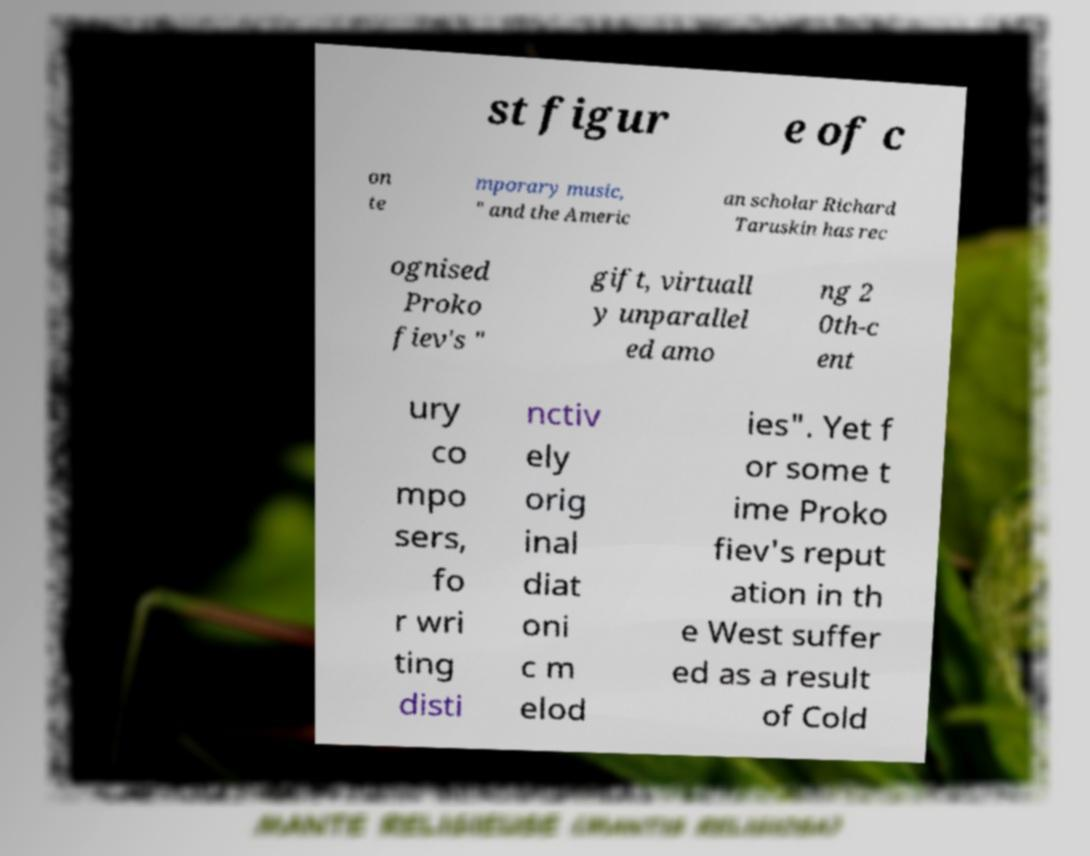Can you accurately transcribe the text from the provided image for me? st figur e of c on te mporary music, " and the Americ an scholar Richard Taruskin has rec ognised Proko fiev's " gift, virtuall y unparallel ed amo ng 2 0th-c ent ury co mpo sers, fo r wri ting disti nctiv ely orig inal diat oni c m elod ies". Yet f or some t ime Proko fiev's reput ation in th e West suffer ed as a result of Cold 